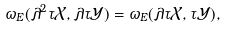Convert formula to latex. <formula><loc_0><loc_0><loc_500><loc_500>\omega _ { E } ( \lambda ^ { 2 } \tau \mathcal { X } , \lambda \tau \mathcal { Y } ) = \omega _ { E } ( \lambda \tau \mathcal { X } , \tau \mathcal { Y } ) ,</formula> 